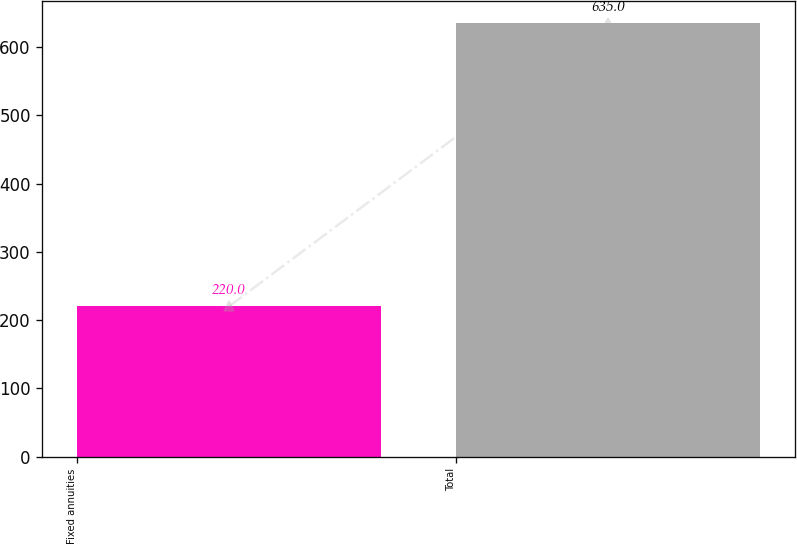<chart> <loc_0><loc_0><loc_500><loc_500><bar_chart><fcel>Fixed annuities<fcel>Total<nl><fcel>220<fcel>635<nl></chart> 